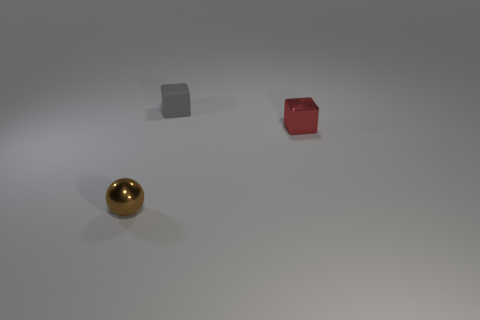Add 3 large cyan rubber cubes. How many objects exist? 6 Subtract all blocks. How many objects are left? 1 Add 1 tiny cubes. How many tiny cubes are left? 3 Add 2 small metal cubes. How many small metal cubes exist? 3 Subtract 0 red spheres. How many objects are left? 3 Subtract all large brown matte things. Subtract all tiny rubber cubes. How many objects are left? 2 